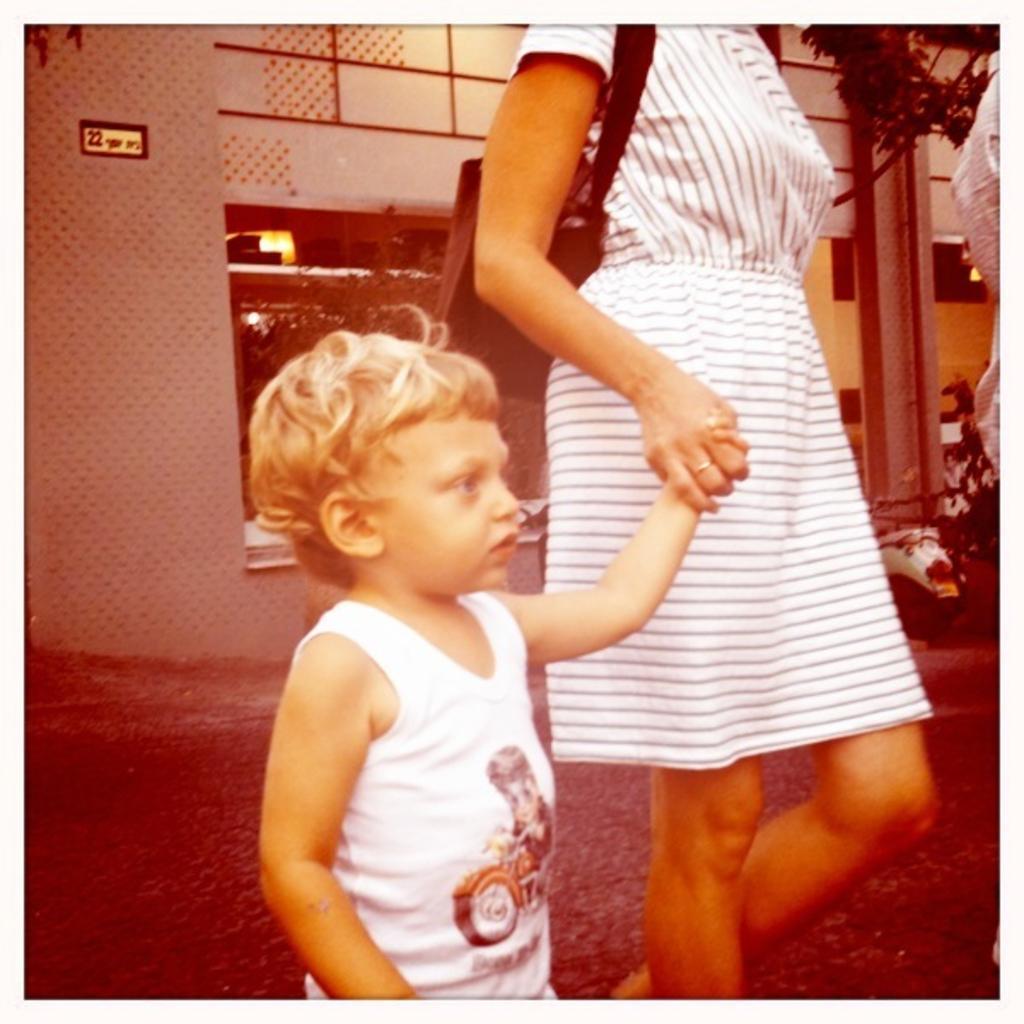Can you describe this image briefly? In the image there is a woman in white dress holding a baby in white vest walking on the road and in the back there is a building with vehicles in front of it on the right side. 